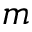Convert formula to latex. <formula><loc_0><loc_0><loc_500><loc_500>m</formula> 